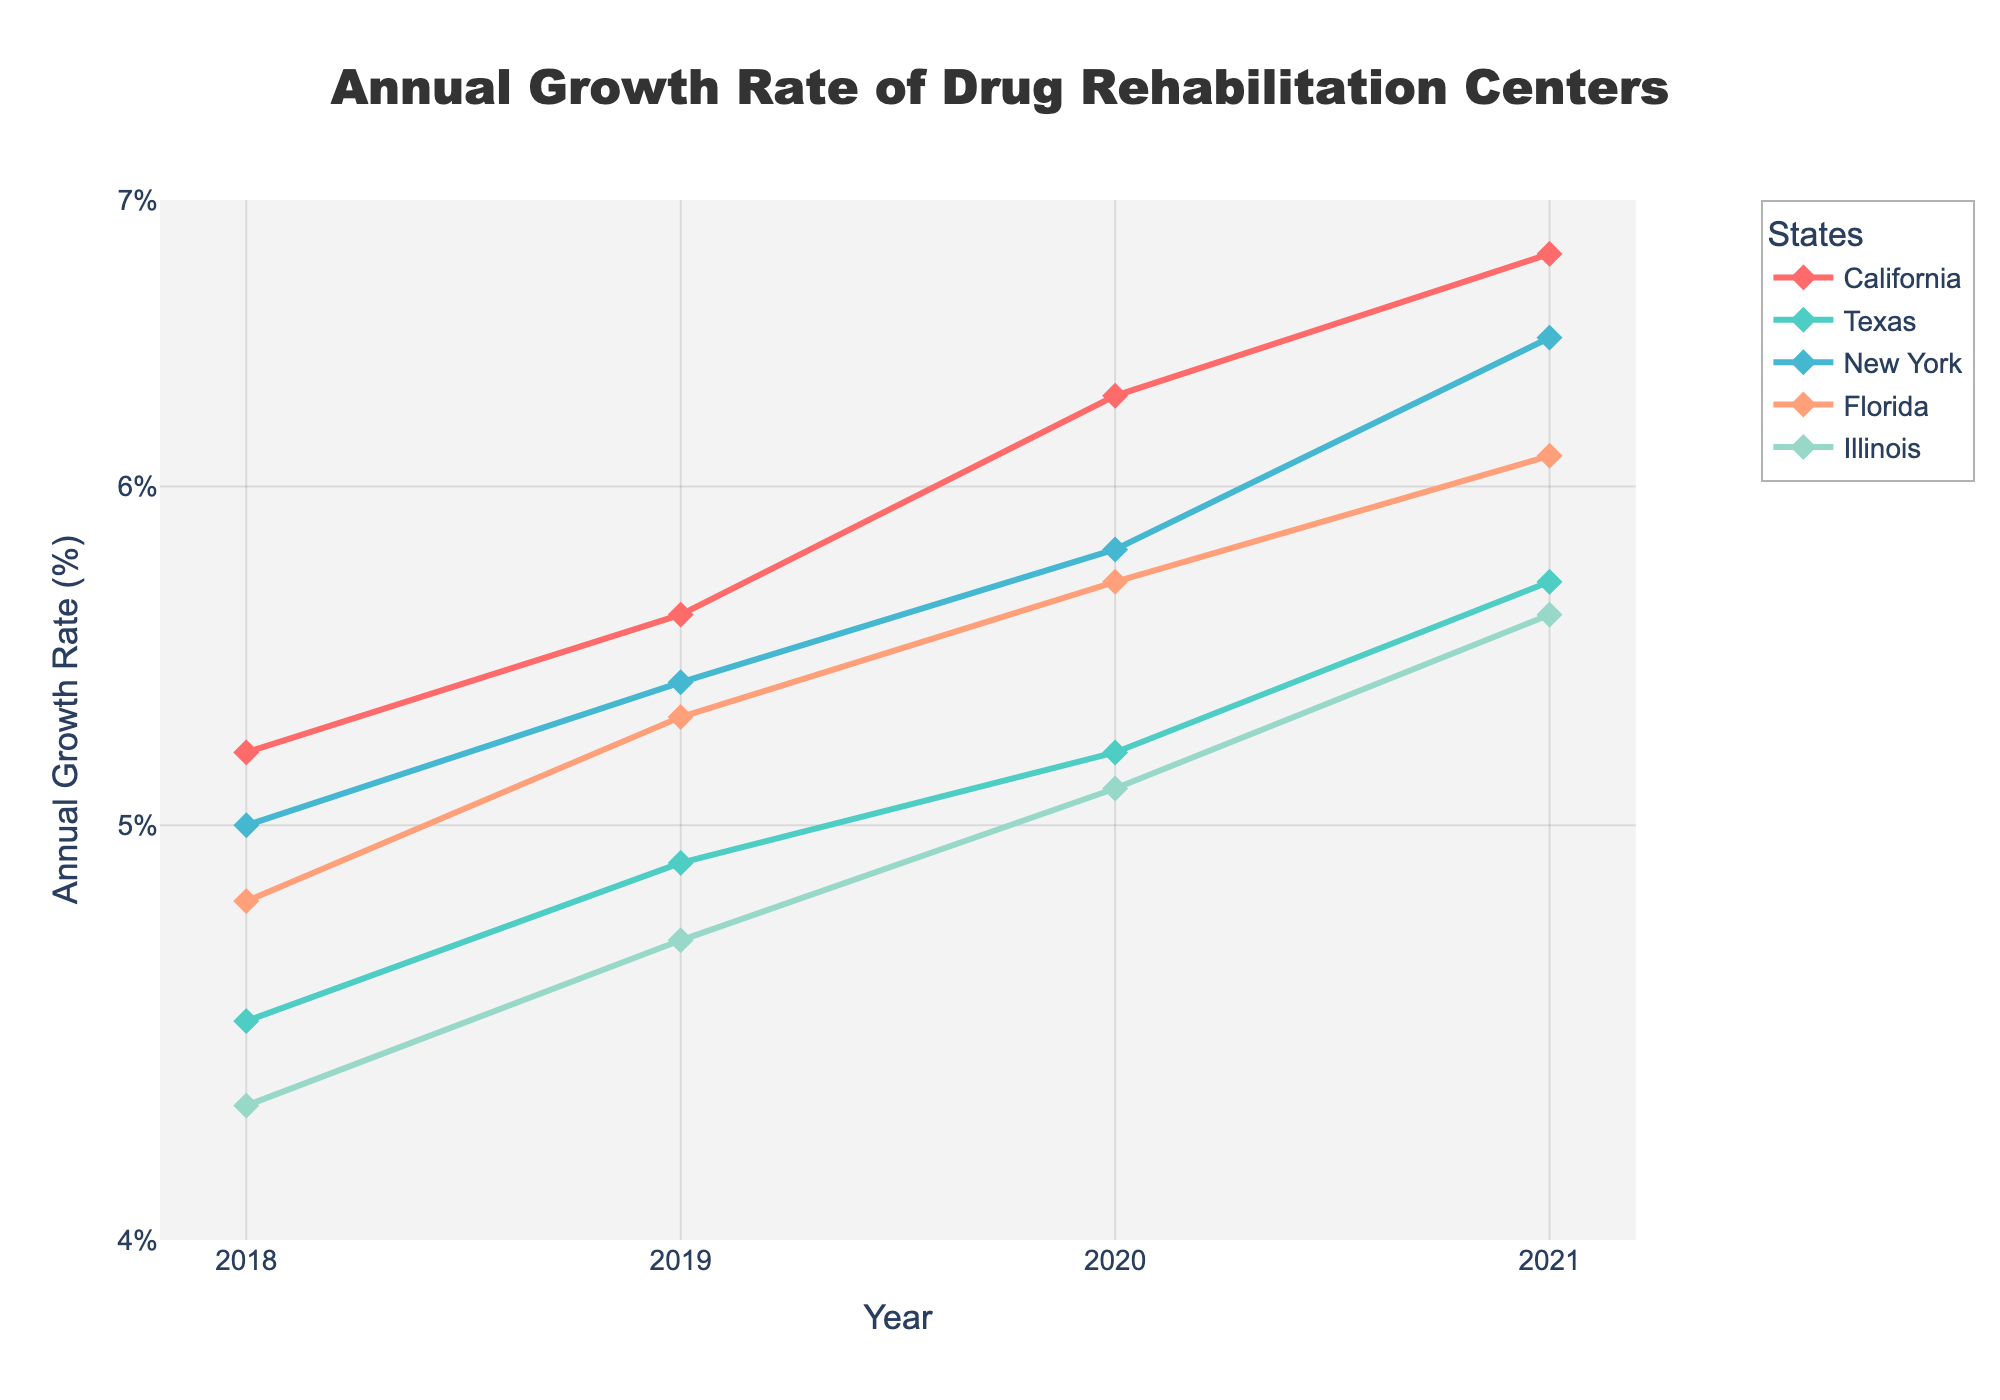What's the title of the figure? The title is located at the top center of the figure and is clear in a larger bold font.
Answer: Annual Growth Rate of Drug Rehabilitation Centers Which state saw the highest annual growth rate in 2021? In 2021, we look at the curves and markers corresponding to each state to find the one positioned highest on the Y-axis.
Answer: California How does the annual growth rate of Illinois in 2020 compare to that in 2018? We find the points for Illinois on the figure for 2020 and 2018, then compare their positions.
Answer: Higher in 2020 Which state has the lowest growth rate in the initial year plotted (2018)? By examining the leftmost points of the lines for all states, we identify the lowest one.
Answer: Illinois What is the trend in the growth rate of each state from 2018 to 2021? For each state, trace the path of the line from 2018 to 2021.
Answer: All states' rates increased Which two states have the closest annual growth rate in 2019? Identify the 2019 data points for each state and compare their Y-axis values to find the closest pair.
Answer: California and New York By how much did the growth rate of Florida change from 2018 to 2021? Calculate the difference between Florida's 2021 and 2018 growth rates by subtracting the 2018 rate from the 2021 rate.
Answer: 1.3% What general pattern is visible in the annual growth rates of drug rehabilitation centers according to the figure? Trace the plotted lines of all states to summarize a common trend from start to end points.
Answer: Increasing trend across all states Which state had the most substantial increase in growth rate from 2018 to 2021? Compare the overall increase by examining the difference between 2021 and 2018 growth rates for each state.
Answer: California On the log scale Y-axis, what are the tick values and their corresponding percentages? The formatted axis shows lines for specific values and converts them into percentages, which are labeled alongside them.
Answer: 4%, 5%, 6%, 7% 